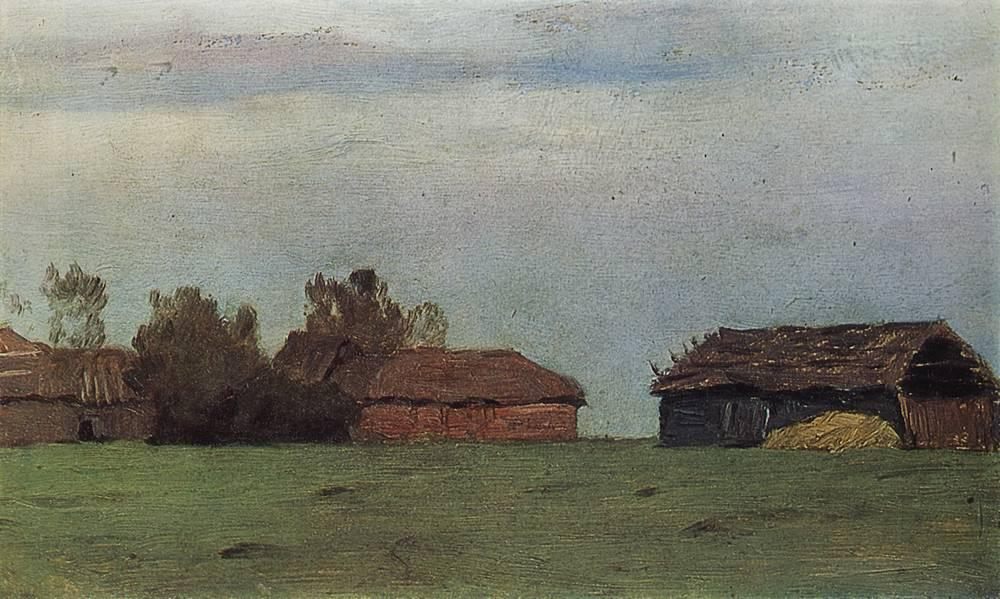Imagine if this setting was part of a film. What type of genre would it fit into, and what would the plot be? This setting would be perfect for a nostalgic, contemplative film, perhaps fitting into the genres of drama or historical romance. The plot might revolve around a family that returns to their ancestral farm to rediscover their roots and mend past conflicts. As they work to restore the old buildings, they uncover secrets about their ancestors, some bittersweet and others full of pride. The serene landscape and the quiet, weathered buildings would provide a poignant backdrop for scenes of reflection, connection, and reconciliation. The film would explore themes of heritage, memory, and the passage of time, with the peaceful setting underscoring the characters' emotional journeys. What kind of emotions does this painting evoke for you? The painting evokes a sense of calm and reflection. The tranquil landscape and the state of the old buildings create a contemplative atmosphere, inviting viewers to pause and consider the passage of time. The absence of human activity adds to the peaceful feeling, suggesting a moment frozen in time. There’s also a touch of nostalgia, as the aged structures hint at stories and lives long past. 